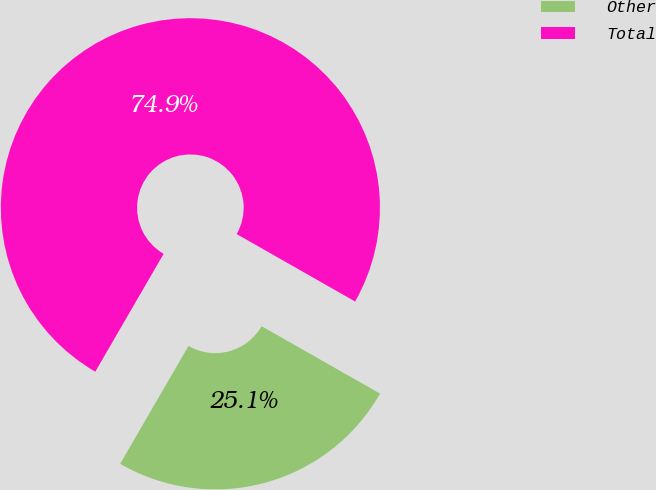<chart> <loc_0><loc_0><loc_500><loc_500><pie_chart><fcel>Other<fcel>Total<nl><fcel>25.13%<fcel>74.87%<nl></chart> 